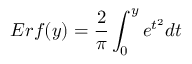<formula> <loc_0><loc_0><loc_500><loc_500>E r f ( y ) = \frac { 2 } { \pi } \int _ { 0 } ^ { y } e ^ { t ^ { 2 } } d t</formula> 